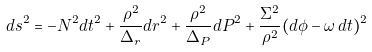Convert formula to latex. <formula><loc_0><loc_0><loc_500><loc_500>d s ^ { 2 } = - N ^ { 2 } d t ^ { 2 } + \frac { \rho ^ { 2 } } { \Delta _ { r } } d r ^ { 2 } + \frac { \rho ^ { 2 } } { \Delta _ { P } } d P ^ { 2 } + \frac { \Sigma ^ { 2 } } { \rho ^ { 2 } } ( d \phi - \omega \, d t ) ^ { 2 }</formula> 